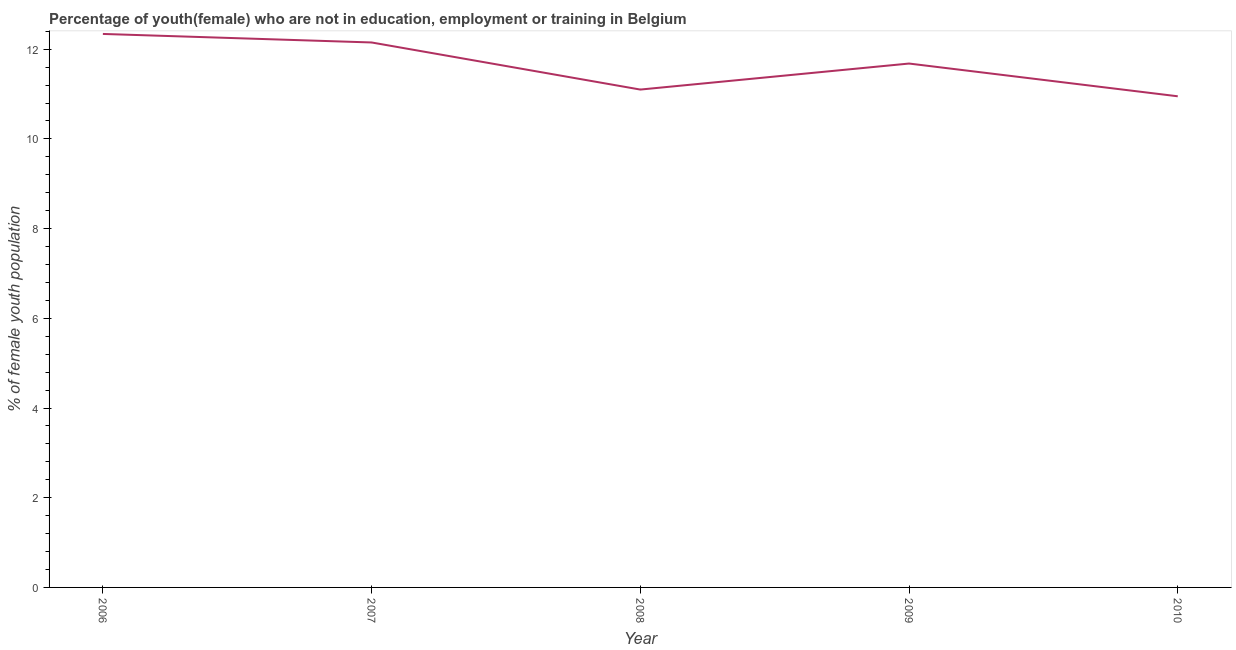What is the unemployed female youth population in 2008?
Your answer should be very brief. 11.1. Across all years, what is the maximum unemployed female youth population?
Keep it short and to the point. 12.34. Across all years, what is the minimum unemployed female youth population?
Provide a succinct answer. 10.95. In which year was the unemployed female youth population minimum?
Offer a terse response. 2010. What is the sum of the unemployed female youth population?
Offer a terse response. 58.22. What is the difference between the unemployed female youth population in 2006 and 2007?
Keep it short and to the point. 0.19. What is the average unemployed female youth population per year?
Your answer should be compact. 11.64. What is the median unemployed female youth population?
Provide a succinct answer. 11.68. Do a majority of the years between 2006 and 2008 (inclusive) have unemployed female youth population greater than 7.6 %?
Offer a terse response. Yes. What is the ratio of the unemployed female youth population in 2007 to that in 2008?
Make the answer very short. 1.09. Is the unemployed female youth population in 2007 less than that in 2010?
Your answer should be very brief. No. What is the difference between the highest and the second highest unemployed female youth population?
Keep it short and to the point. 0.19. What is the difference between the highest and the lowest unemployed female youth population?
Offer a very short reply. 1.39. In how many years, is the unemployed female youth population greater than the average unemployed female youth population taken over all years?
Offer a very short reply. 3. How many years are there in the graph?
Offer a very short reply. 5. What is the difference between two consecutive major ticks on the Y-axis?
Ensure brevity in your answer.  2. Are the values on the major ticks of Y-axis written in scientific E-notation?
Your response must be concise. No. Does the graph contain any zero values?
Your answer should be very brief. No. What is the title of the graph?
Offer a terse response. Percentage of youth(female) who are not in education, employment or training in Belgium. What is the label or title of the X-axis?
Make the answer very short. Year. What is the label or title of the Y-axis?
Offer a terse response. % of female youth population. What is the % of female youth population in 2006?
Your answer should be compact. 12.34. What is the % of female youth population of 2007?
Offer a very short reply. 12.15. What is the % of female youth population in 2008?
Provide a short and direct response. 11.1. What is the % of female youth population of 2009?
Your answer should be very brief. 11.68. What is the % of female youth population of 2010?
Make the answer very short. 10.95. What is the difference between the % of female youth population in 2006 and 2007?
Offer a terse response. 0.19. What is the difference between the % of female youth population in 2006 and 2008?
Make the answer very short. 1.24. What is the difference between the % of female youth population in 2006 and 2009?
Your answer should be compact. 0.66. What is the difference between the % of female youth population in 2006 and 2010?
Provide a short and direct response. 1.39. What is the difference between the % of female youth population in 2007 and 2008?
Ensure brevity in your answer.  1.05. What is the difference between the % of female youth population in 2007 and 2009?
Offer a very short reply. 0.47. What is the difference between the % of female youth population in 2008 and 2009?
Keep it short and to the point. -0.58. What is the difference between the % of female youth population in 2008 and 2010?
Provide a short and direct response. 0.15. What is the difference between the % of female youth population in 2009 and 2010?
Your answer should be compact. 0.73. What is the ratio of the % of female youth population in 2006 to that in 2007?
Your response must be concise. 1.02. What is the ratio of the % of female youth population in 2006 to that in 2008?
Your response must be concise. 1.11. What is the ratio of the % of female youth population in 2006 to that in 2009?
Provide a short and direct response. 1.06. What is the ratio of the % of female youth population in 2006 to that in 2010?
Ensure brevity in your answer.  1.13. What is the ratio of the % of female youth population in 2007 to that in 2008?
Offer a terse response. 1.09. What is the ratio of the % of female youth population in 2007 to that in 2009?
Make the answer very short. 1.04. What is the ratio of the % of female youth population in 2007 to that in 2010?
Your answer should be compact. 1.11. What is the ratio of the % of female youth population in 2009 to that in 2010?
Your answer should be compact. 1.07. 